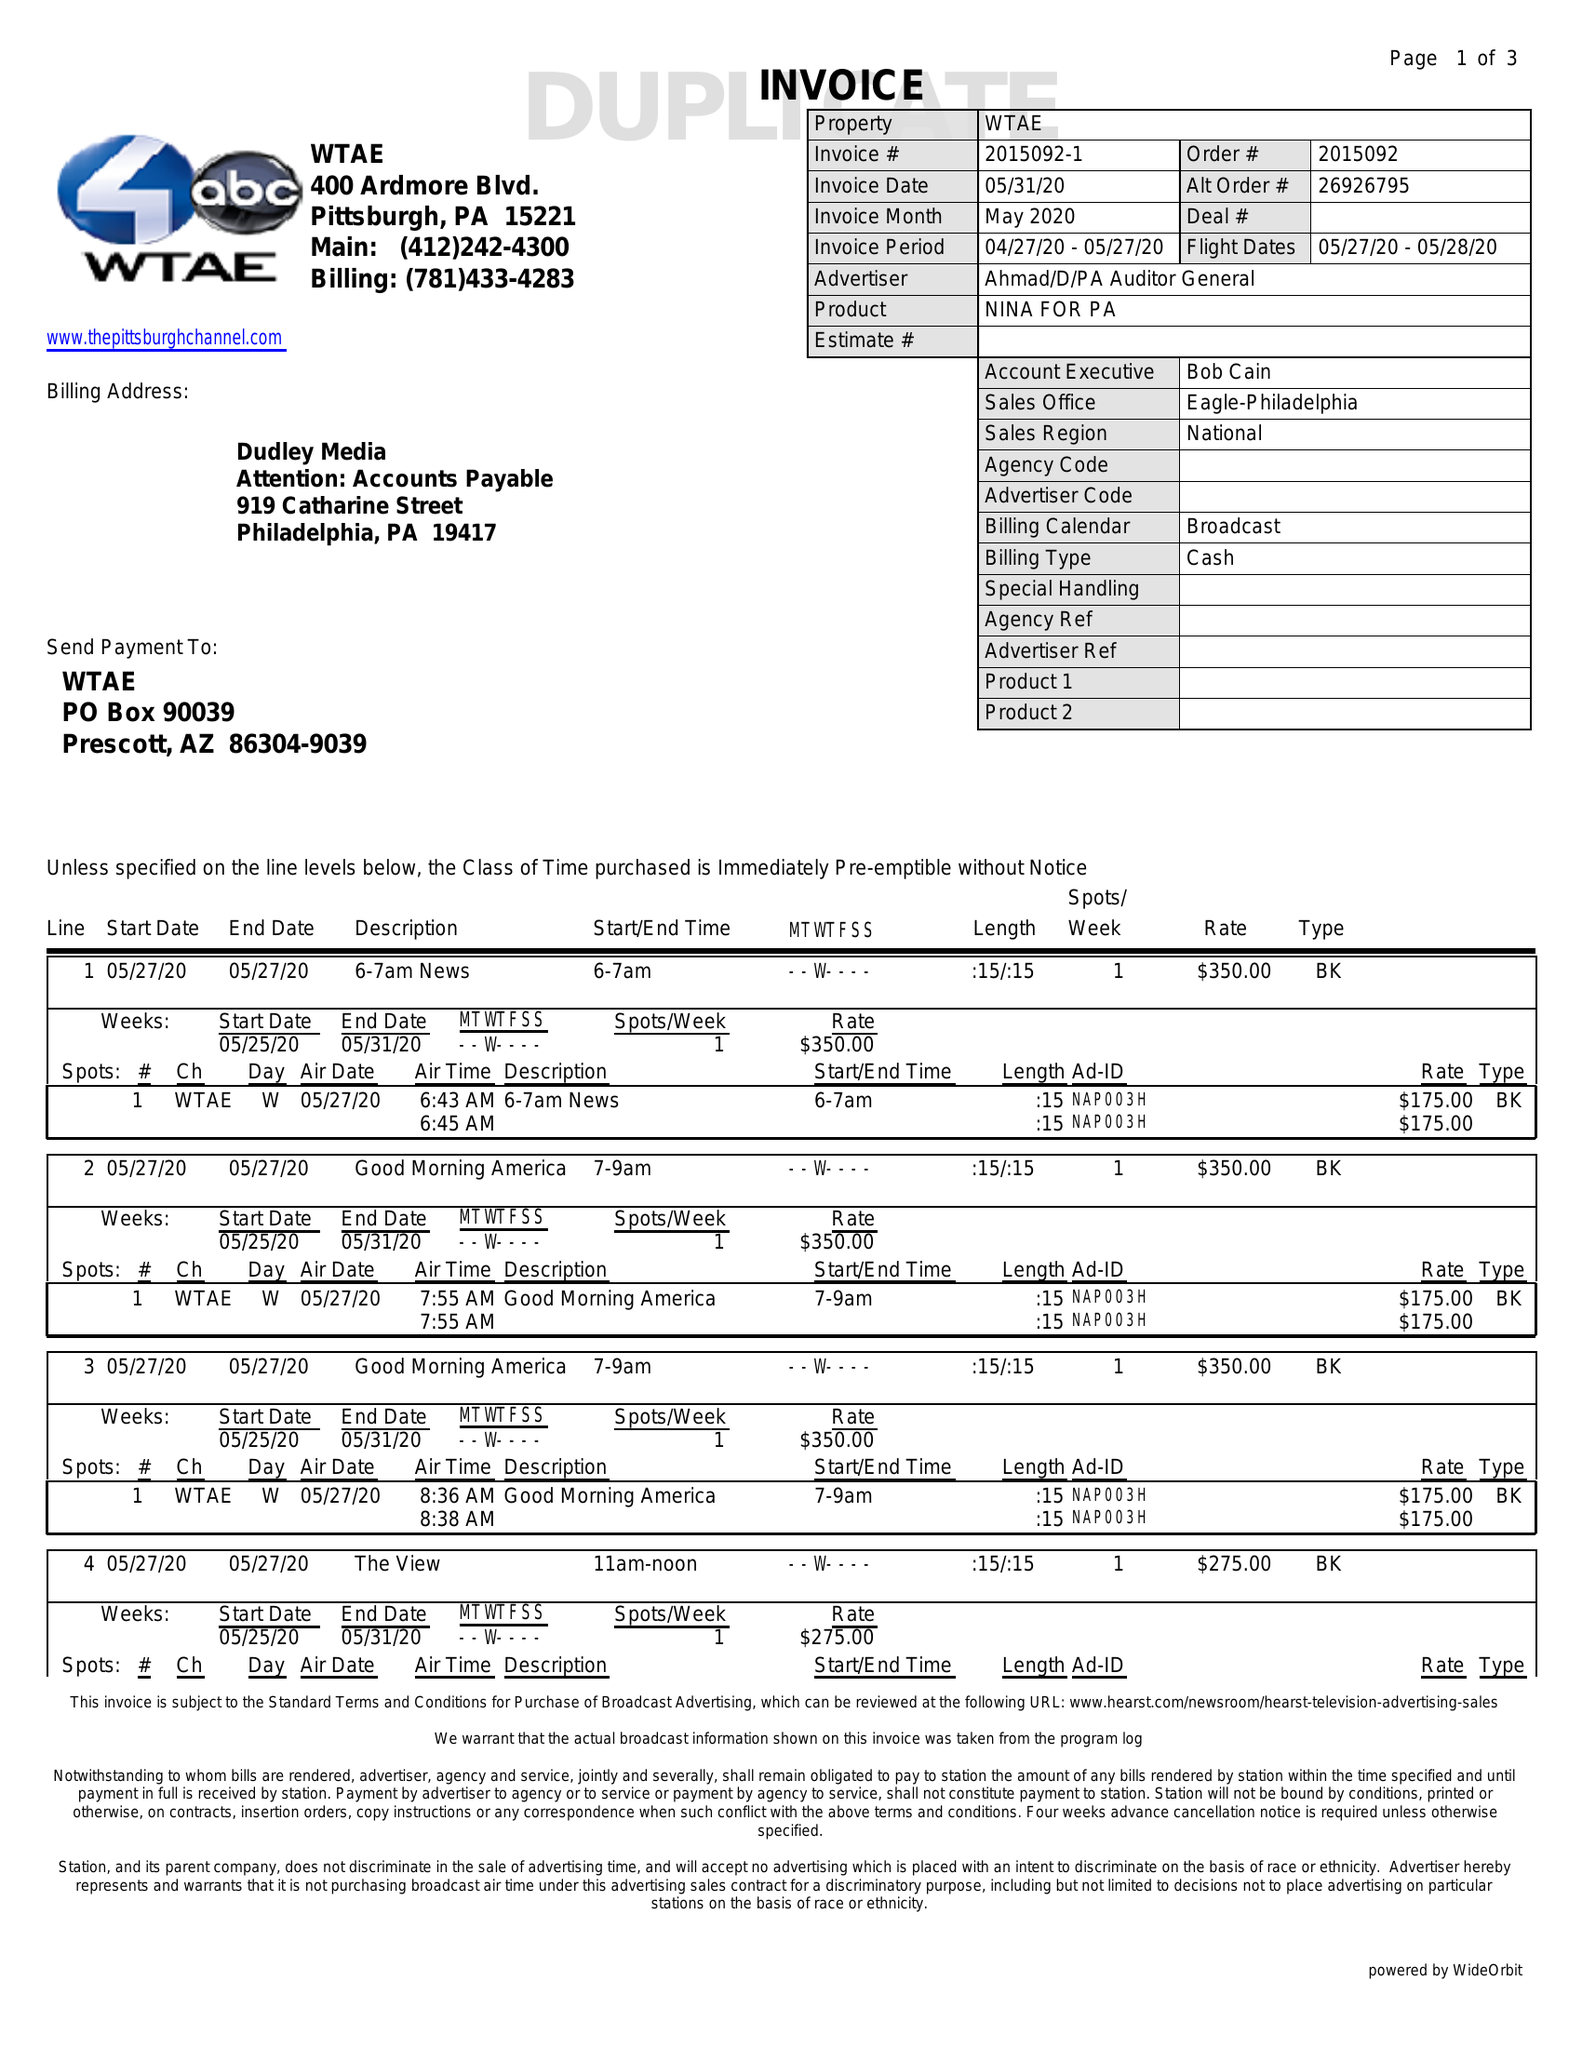What is the value for the flight_from?
Answer the question using a single word or phrase. 05/27/20 